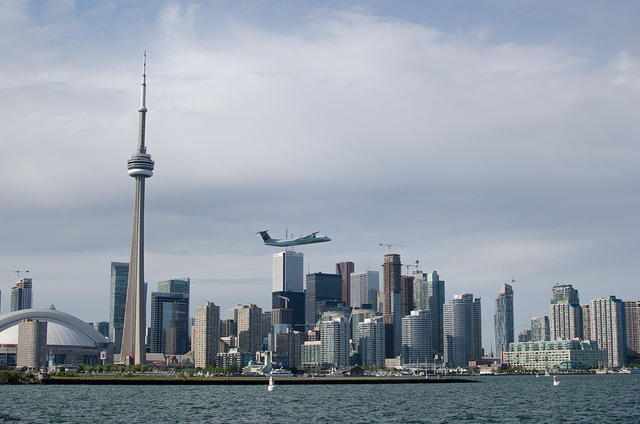<image>What body of water is that? I don't know what body of water is that. It can be a river, bay, lake, or ocean. What is the name of this river? I don't know the name of the river. It could be Washington, Duwamish, Hudson, Union, Wabash, or Missouri river. What city skyline is this a picture of? I am not sure what city skyline this is. It could be either Seattle or New York. What body of water is that? I don't know what body of water is that. It can be a river, bay, Sydney Harbor, Pacific Ocean, Lake Ontario or ocean. What is the name of this river? I don't know the name of this river. It can be Washington, Duwamish, Hudson, Union, Wabash, Seattle, or Missouri River. What city skyline is this a picture of? I am not sure what city skyline is in the picture. It can be either New York or Seattle. 